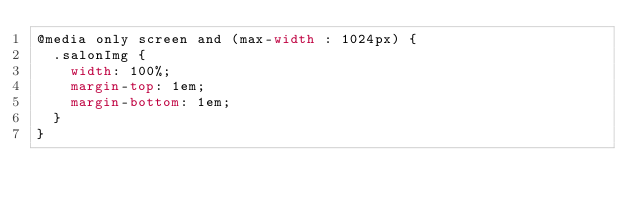<code> <loc_0><loc_0><loc_500><loc_500><_CSS_>@media only screen and (max-width : 1024px) {
  .salonImg {
    width: 100%;
    margin-top: 1em;
    margin-bottom: 1em;
  }
}</code> 